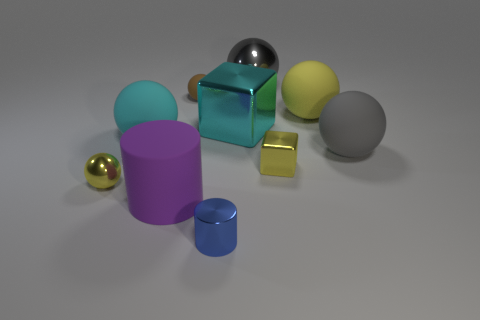Subtract all big metallic spheres. How many spheres are left? 5 Subtract all yellow balls. How many balls are left? 4 Subtract all blue balls. Subtract all blue cylinders. How many balls are left? 6 Subtract all balls. How many objects are left? 4 Subtract 0 purple blocks. How many objects are left? 10 Subtract all big purple objects. Subtract all yellow rubber objects. How many objects are left? 8 Add 3 gray rubber things. How many gray rubber things are left? 4 Add 1 small red matte blocks. How many small red matte blocks exist? 1 